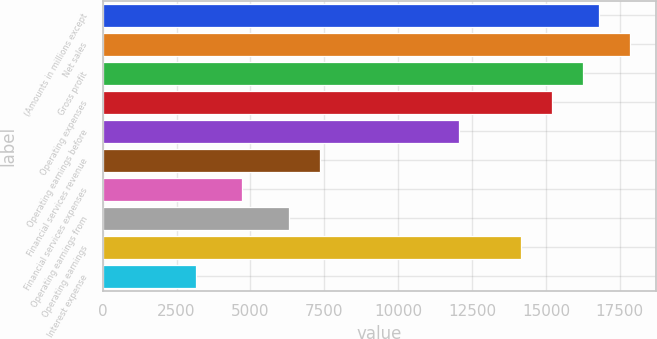Convert chart. <chart><loc_0><loc_0><loc_500><loc_500><bar_chart><fcel>(Amounts in millions except<fcel>Net sales<fcel>Gross profit<fcel>Operating expenses<fcel>Operating earnings before<fcel>Financial services revenue<fcel>Financial services expenses<fcel>Operating earnings from<fcel>Operating earnings<fcel>Interest expense<nl><fcel>16794.5<fcel>17844.1<fcel>16269.7<fcel>15220.1<fcel>12071.4<fcel>7348.26<fcel>4724.31<fcel>6298.68<fcel>14170.5<fcel>3149.94<nl></chart> 